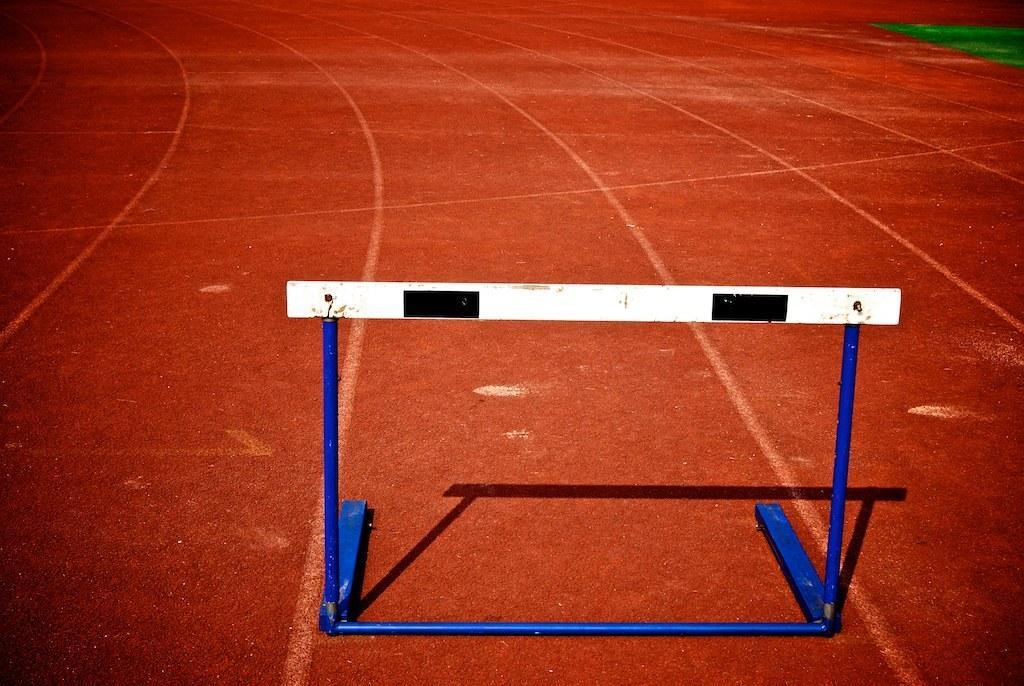How would you summarize this image in a sentence or two? In this image we can see a stand placed on the ground. 